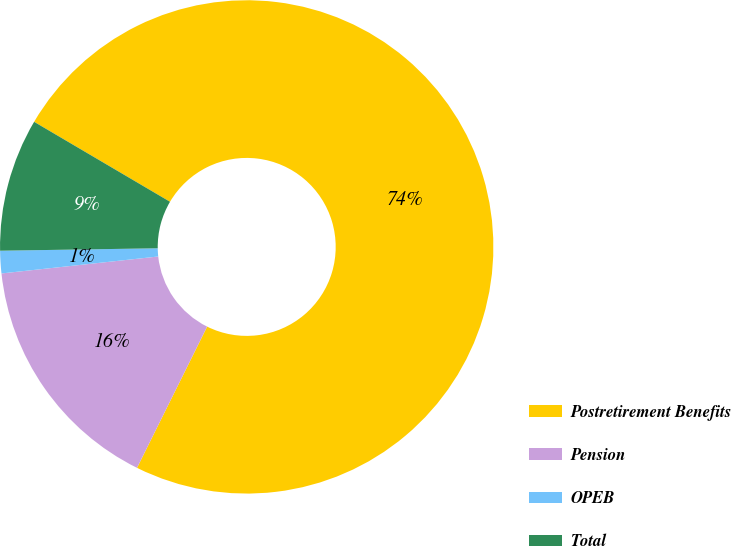Convert chart to OTSL. <chart><loc_0><loc_0><loc_500><loc_500><pie_chart><fcel>Postretirement Benefits<fcel>Pension<fcel>OPEB<fcel>Total<nl><fcel>73.87%<fcel>15.95%<fcel>1.47%<fcel>8.71%<nl></chart> 